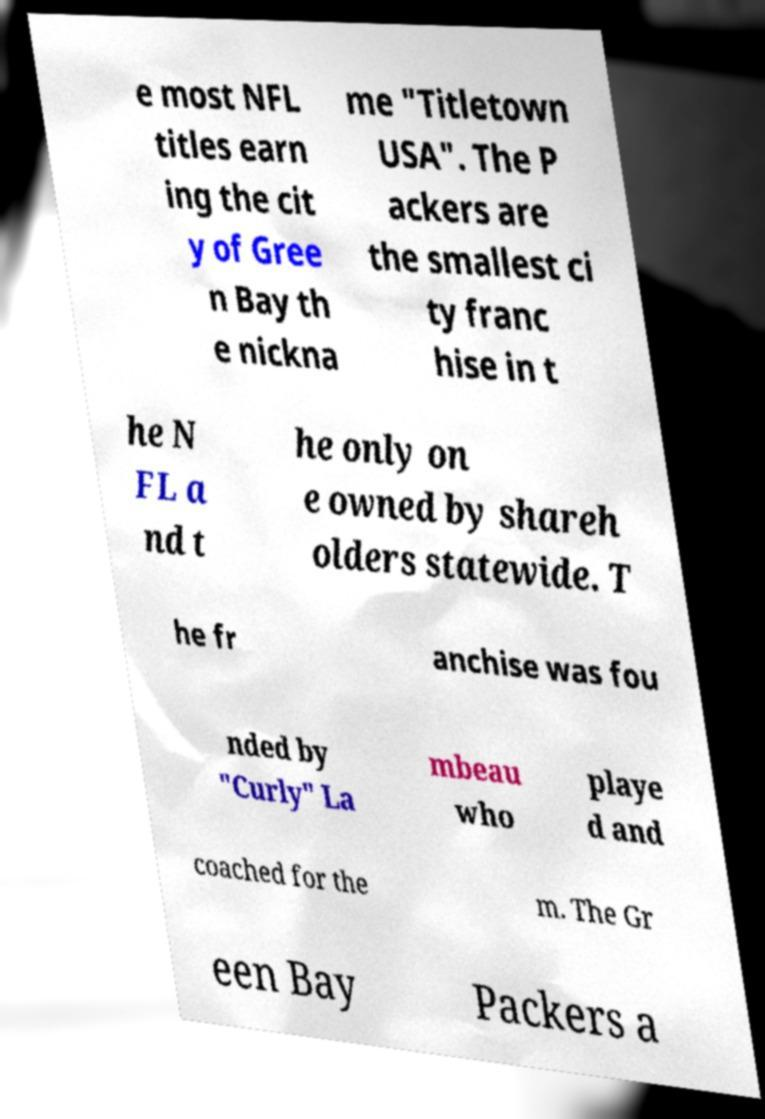Can you accurately transcribe the text from the provided image for me? e most NFL titles earn ing the cit y of Gree n Bay th e nickna me "Titletown USA". The P ackers are the smallest ci ty franc hise in t he N FL a nd t he only on e owned by shareh olders statewide. T he fr anchise was fou nded by "Curly" La mbeau who playe d and coached for the m. The Gr een Bay Packers a 